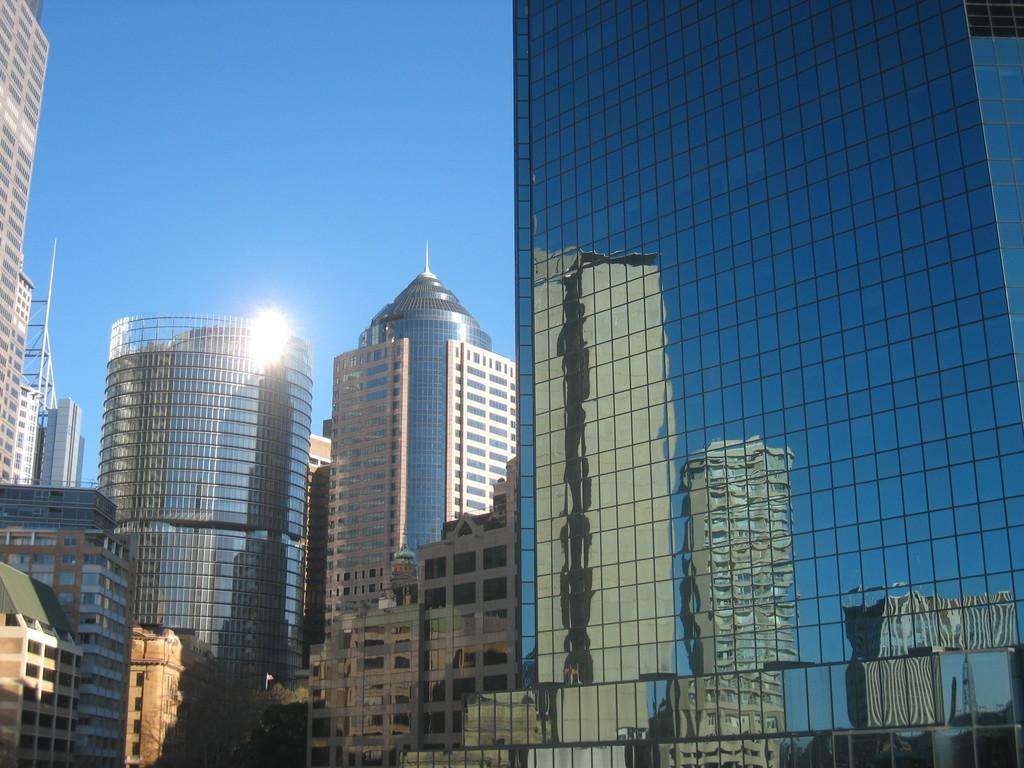Please provide a concise description of this image. This picture contains buildings which are in blue, white and brown color. At the top of the picture, we see the sky, which is blue in color. We even see the sun. This picture is clicked outside the city. 